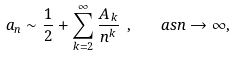<formula> <loc_0><loc_0><loc_500><loc_500>a _ { n } \sim \frac { 1 } { 2 } + \sum _ { k = 2 } ^ { \infty } \frac { A _ { k } } { n ^ { k } } \ , \quad a s n \to \infty ,</formula> 